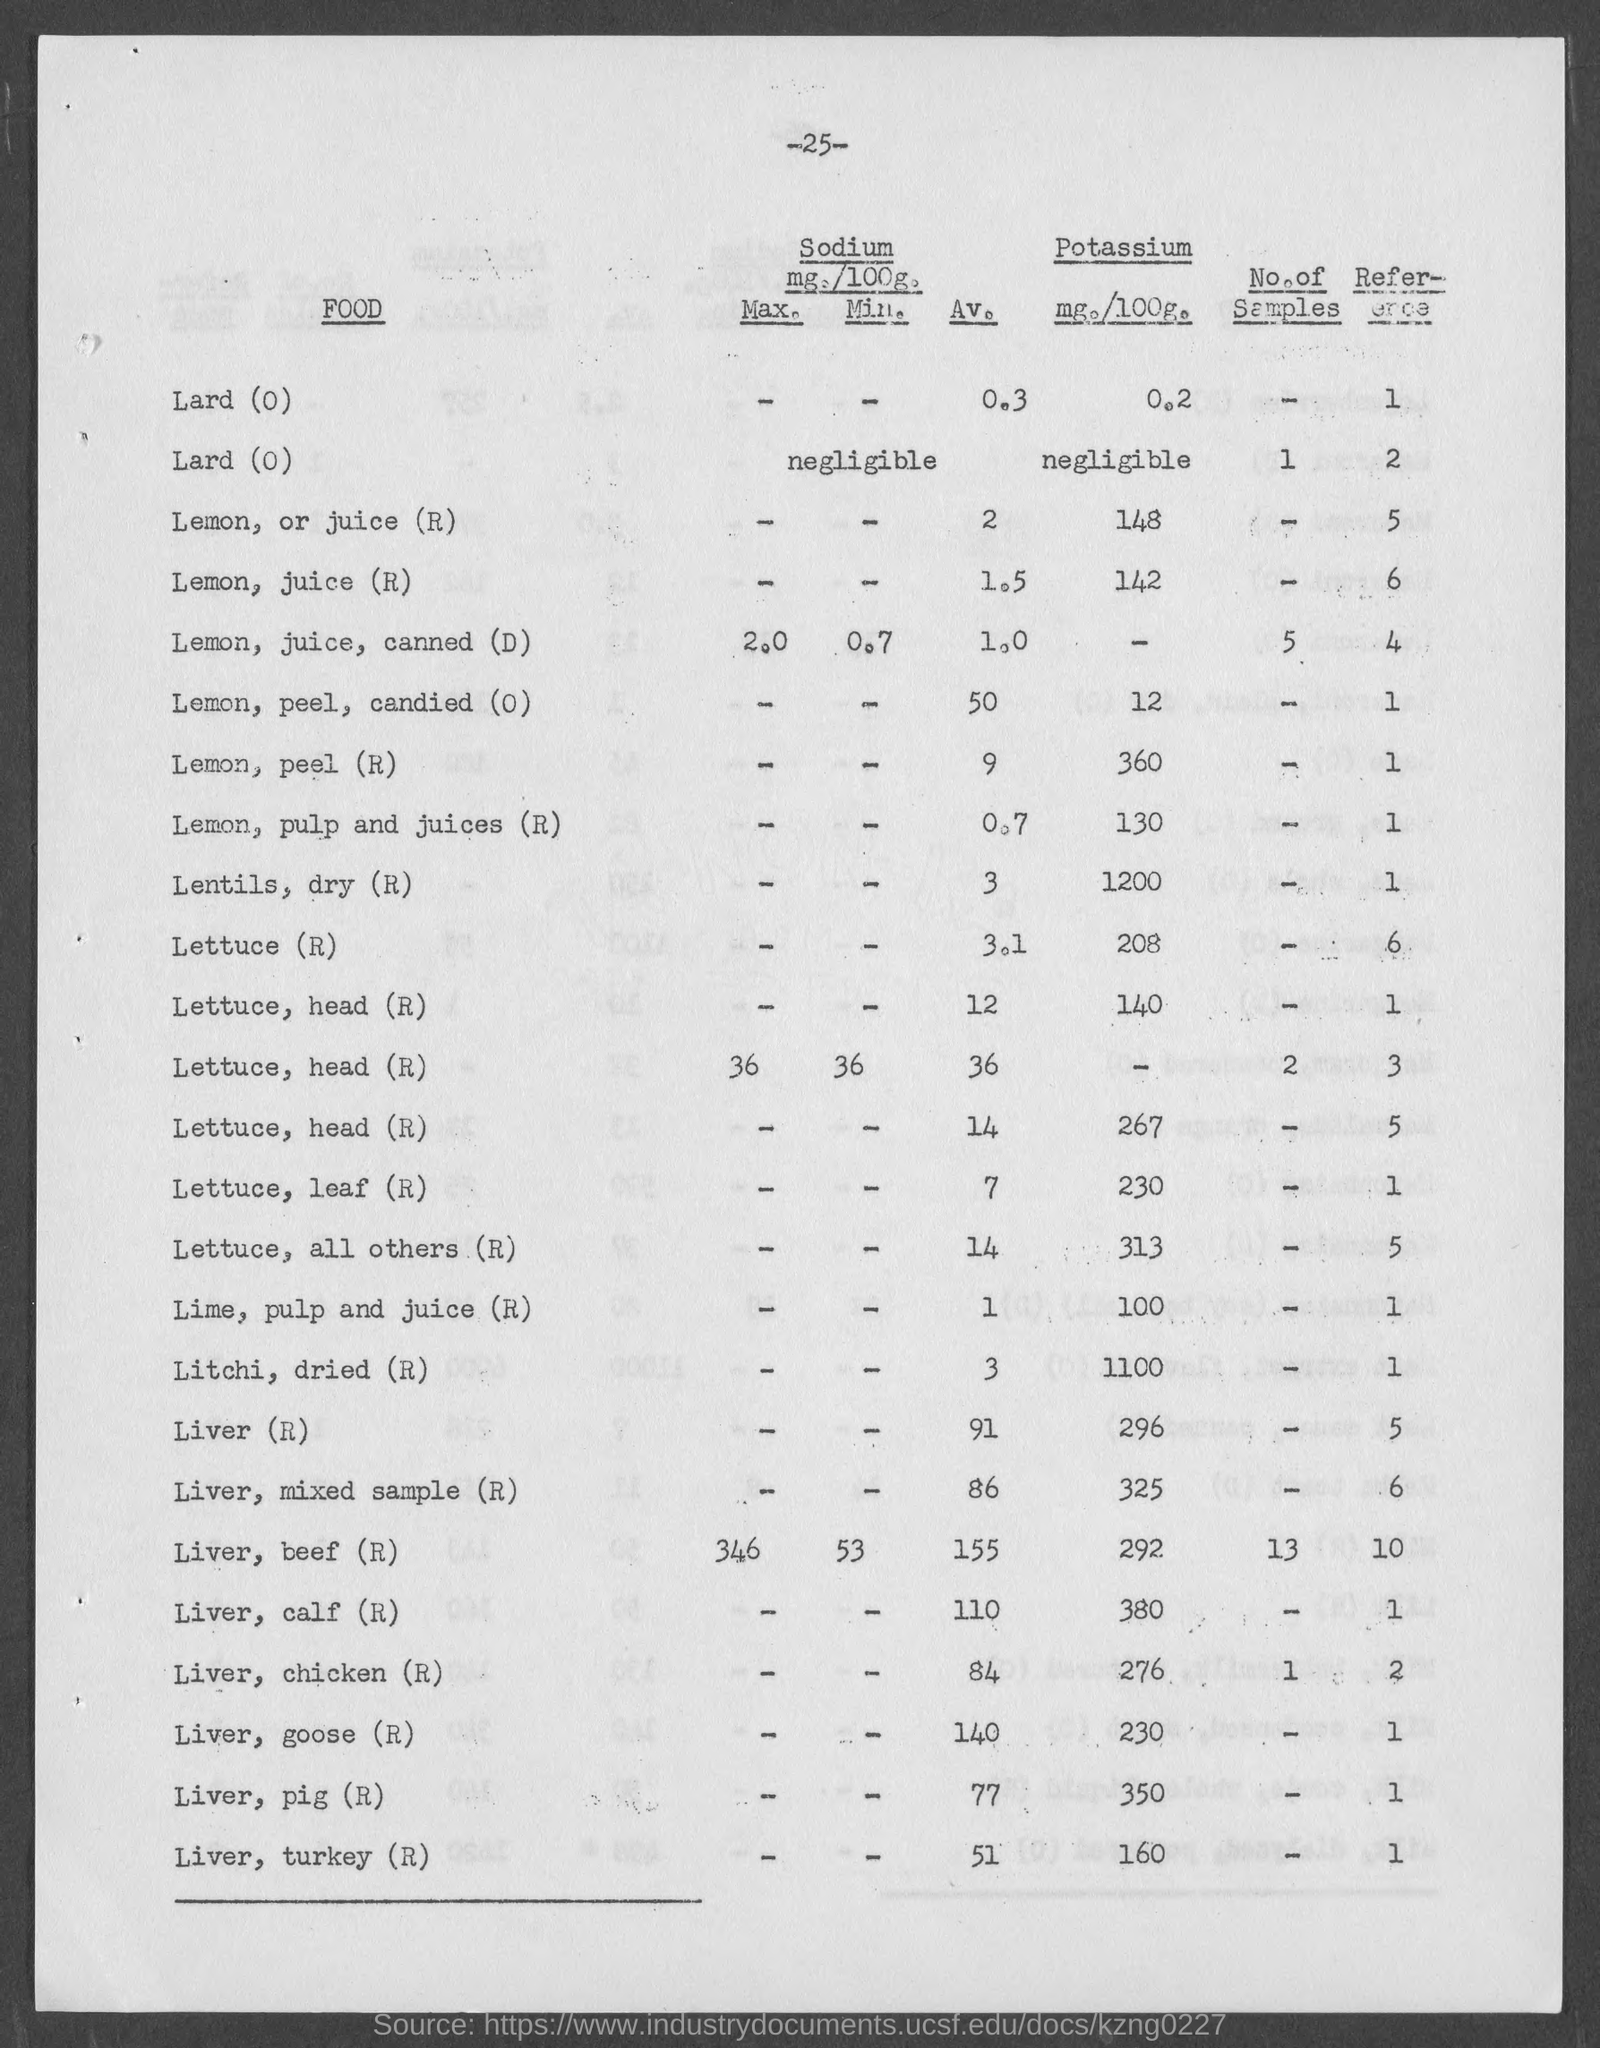Give some essential details in this illustration. The amount of potassium in lemons, specifically in the peel, is mentioned on the given page as 360. The amount of potassium present in lemon or its juice is mentioned on the given page as 148. The given page states that lettuce contains 208 milligrams of potassium per serving. The average value of sodium in lemon juice, as mentioned in the given page, is 2. The amount of potassium present in liver, as mentioned on the given page, is 296 mg per 100 g of liver. 